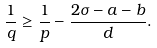<formula> <loc_0><loc_0><loc_500><loc_500>\frac { 1 } { q } \geq \frac { 1 } { p } - \frac { 2 \sigma - a - b } { d } .</formula> 